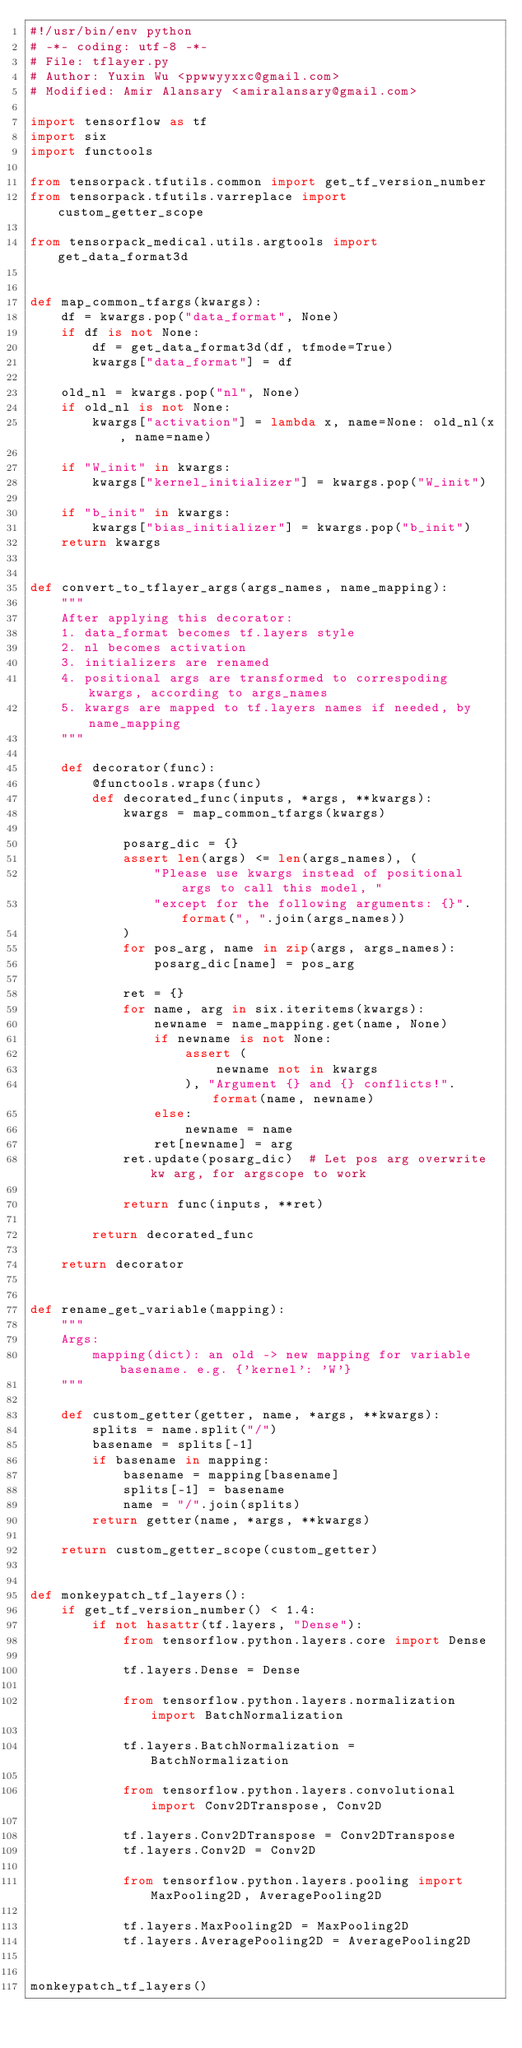Convert code to text. <code><loc_0><loc_0><loc_500><loc_500><_Python_>#!/usr/bin/env python
# -*- coding: utf-8 -*-
# File: tflayer.py
# Author: Yuxin Wu <ppwwyyxxc@gmail.com>
# Modified: Amir Alansary <amiralansary@gmail.com>

import tensorflow as tf
import six
import functools

from tensorpack.tfutils.common import get_tf_version_number
from tensorpack.tfutils.varreplace import custom_getter_scope

from tensorpack_medical.utils.argtools import get_data_format3d


def map_common_tfargs(kwargs):
    df = kwargs.pop("data_format", None)
    if df is not None:
        df = get_data_format3d(df, tfmode=True)
        kwargs["data_format"] = df

    old_nl = kwargs.pop("nl", None)
    if old_nl is not None:
        kwargs["activation"] = lambda x, name=None: old_nl(x, name=name)

    if "W_init" in kwargs:
        kwargs["kernel_initializer"] = kwargs.pop("W_init")

    if "b_init" in kwargs:
        kwargs["bias_initializer"] = kwargs.pop("b_init")
    return kwargs


def convert_to_tflayer_args(args_names, name_mapping):
    """
    After applying this decorator:
    1. data_format becomes tf.layers style
    2. nl becomes activation
    3. initializers are renamed
    4. positional args are transformed to correspoding kwargs, according to args_names
    5. kwargs are mapped to tf.layers names if needed, by name_mapping
    """

    def decorator(func):
        @functools.wraps(func)
        def decorated_func(inputs, *args, **kwargs):
            kwargs = map_common_tfargs(kwargs)

            posarg_dic = {}
            assert len(args) <= len(args_names), (
                "Please use kwargs instead of positional args to call this model, "
                "except for the following arguments: {}".format(", ".join(args_names))
            )
            for pos_arg, name in zip(args, args_names):
                posarg_dic[name] = pos_arg

            ret = {}
            for name, arg in six.iteritems(kwargs):
                newname = name_mapping.get(name, None)
                if newname is not None:
                    assert (
                        newname not in kwargs
                    ), "Argument {} and {} conflicts!".format(name, newname)
                else:
                    newname = name
                ret[newname] = arg
            ret.update(posarg_dic)  # Let pos arg overwrite kw arg, for argscope to work

            return func(inputs, **ret)

        return decorated_func

    return decorator


def rename_get_variable(mapping):
    """
    Args:
        mapping(dict): an old -> new mapping for variable basename. e.g. {'kernel': 'W'}
    """

    def custom_getter(getter, name, *args, **kwargs):
        splits = name.split("/")
        basename = splits[-1]
        if basename in mapping:
            basename = mapping[basename]
            splits[-1] = basename
            name = "/".join(splits)
        return getter(name, *args, **kwargs)

    return custom_getter_scope(custom_getter)


def monkeypatch_tf_layers():
    if get_tf_version_number() < 1.4:
        if not hasattr(tf.layers, "Dense"):
            from tensorflow.python.layers.core import Dense

            tf.layers.Dense = Dense

            from tensorflow.python.layers.normalization import BatchNormalization

            tf.layers.BatchNormalization = BatchNormalization

            from tensorflow.python.layers.convolutional import Conv2DTranspose, Conv2D

            tf.layers.Conv2DTranspose = Conv2DTranspose
            tf.layers.Conv2D = Conv2D

            from tensorflow.python.layers.pooling import MaxPooling2D, AveragePooling2D

            tf.layers.MaxPooling2D = MaxPooling2D
            tf.layers.AveragePooling2D = AveragePooling2D


monkeypatch_tf_layers()
</code> 